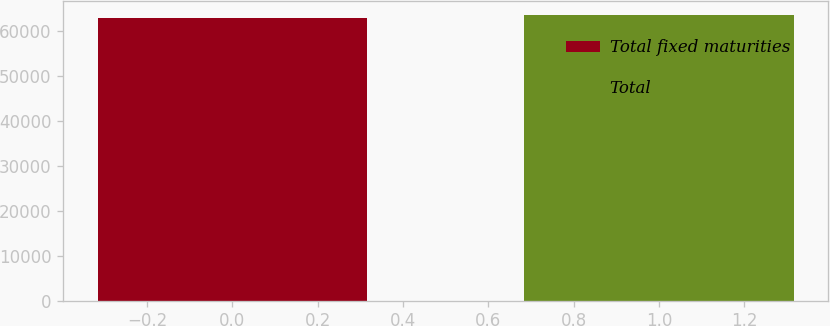<chart> <loc_0><loc_0><loc_500><loc_500><bar_chart><fcel>Total fixed maturities<fcel>Total<nl><fcel>62820<fcel>63438<nl></chart> 